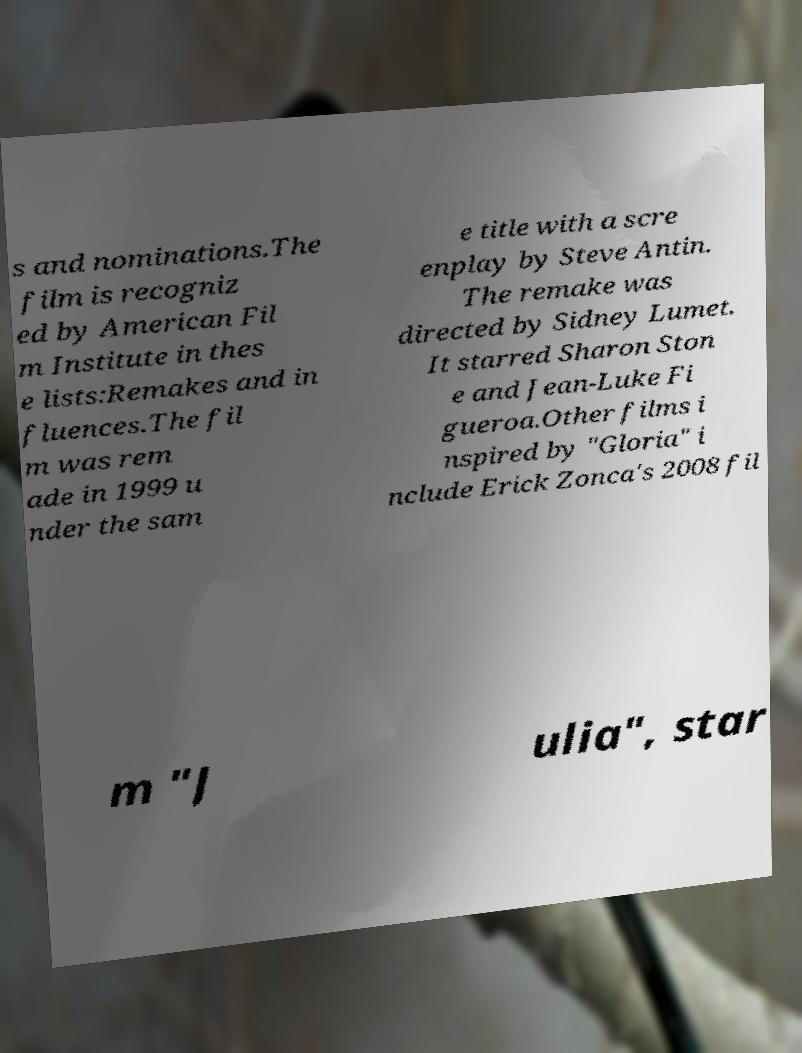What messages or text are displayed in this image? I need them in a readable, typed format. s and nominations.The film is recogniz ed by American Fil m Institute in thes e lists:Remakes and in fluences.The fil m was rem ade in 1999 u nder the sam e title with a scre enplay by Steve Antin. The remake was directed by Sidney Lumet. It starred Sharon Ston e and Jean-Luke Fi gueroa.Other films i nspired by "Gloria" i nclude Erick Zonca's 2008 fil m "J ulia", star 